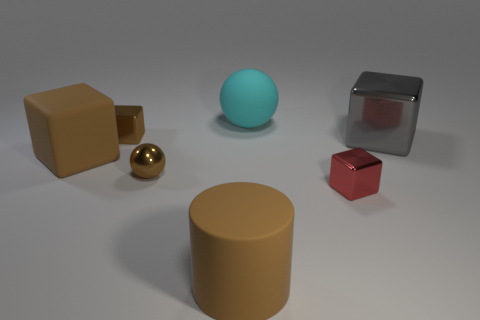Subtract all gray metal cubes. How many cubes are left? 3 Subtract all red cubes. How many cubes are left? 3 Add 1 gray metallic cubes. How many objects exist? 8 Subtract all brown cylinders. How many brown cubes are left? 2 Subtract 0 blue cubes. How many objects are left? 7 Subtract all blocks. How many objects are left? 3 Subtract 4 cubes. How many cubes are left? 0 Subtract all cyan cubes. Subtract all purple cylinders. How many cubes are left? 4 Subtract all tiny blue cylinders. Subtract all tiny red blocks. How many objects are left? 6 Add 5 large objects. How many large objects are left? 9 